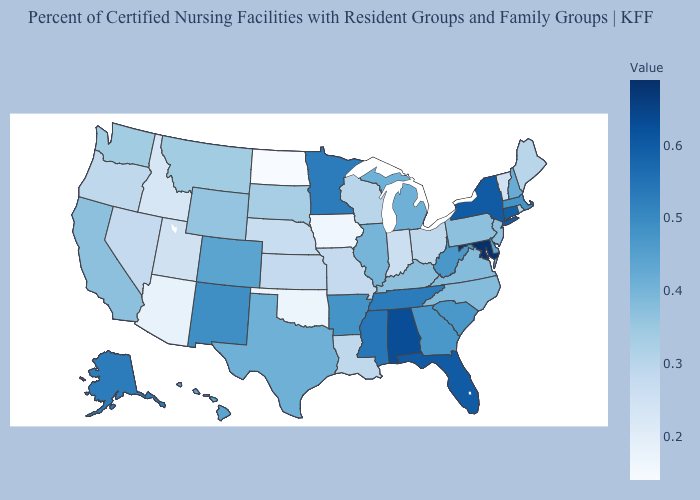Among the states that border Oklahoma , does New Mexico have the highest value?
Quick response, please. Yes. Does Mississippi have the highest value in the USA?
Give a very brief answer. No. Does North Dakota have the lowest value in the MidWest?
Be succinct. Yes. Which states have the highest value in the USA?
Keep it brief. Maryland. Which states have the highest value in the USA?
Quick response, please. Maryland. Does Maryland have the highest value in the USA?
Quick response, please. Yes. Among the states that border Connecticut , which have the lowest value?
Give a very brief answer. Rhode Island. 